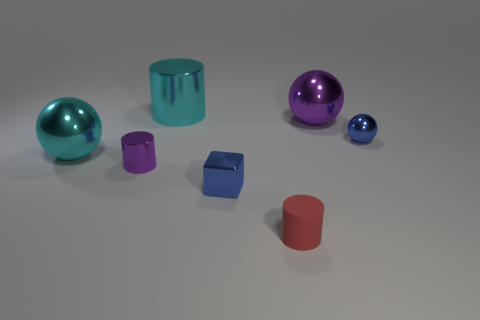Add 1 brown rubber spheres. How many objects exist? 8 Subtract all cylinders. How many objects are left? 4 Add 4 purple cylinders. How many purple cylinders are left? 5 Add 5 tiny purple matte objects. How many tiny purple matte objects exist? 5 Subtract 0 green cylinders. How many objects are left? 7 Subtract all small purple metallic cylinders. Subtract all cyan metal spheres. How many objects are left? 5 